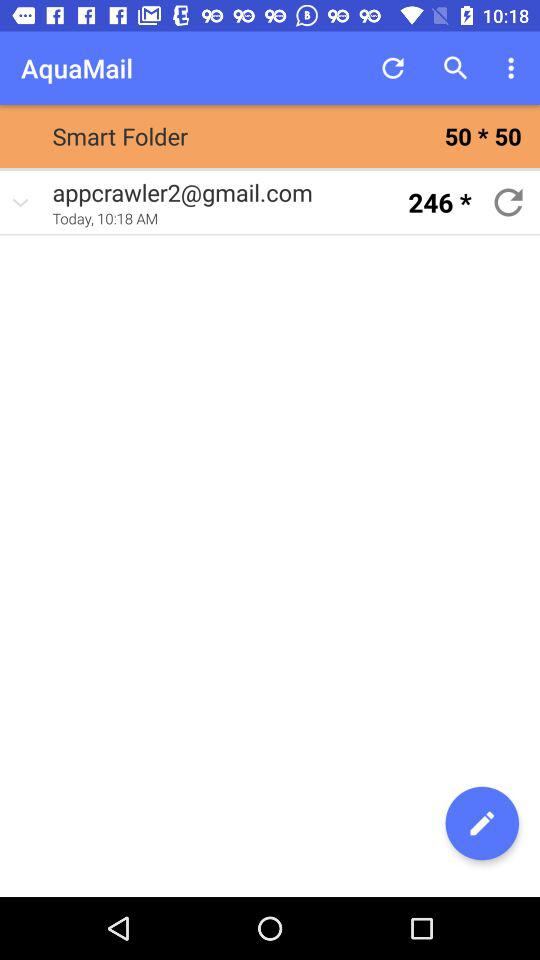At what time is mail received? The time at which the mail is received is 10:18 AM. 